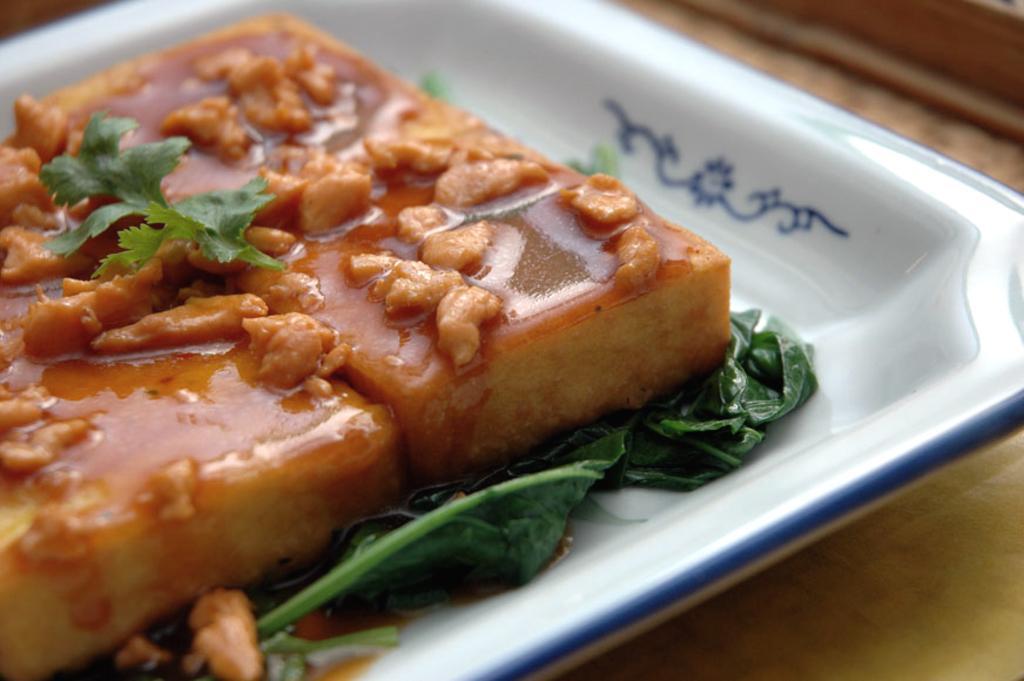Describe this image in one or two sentences. In this picture I can see a food item on the plate, on an object. 